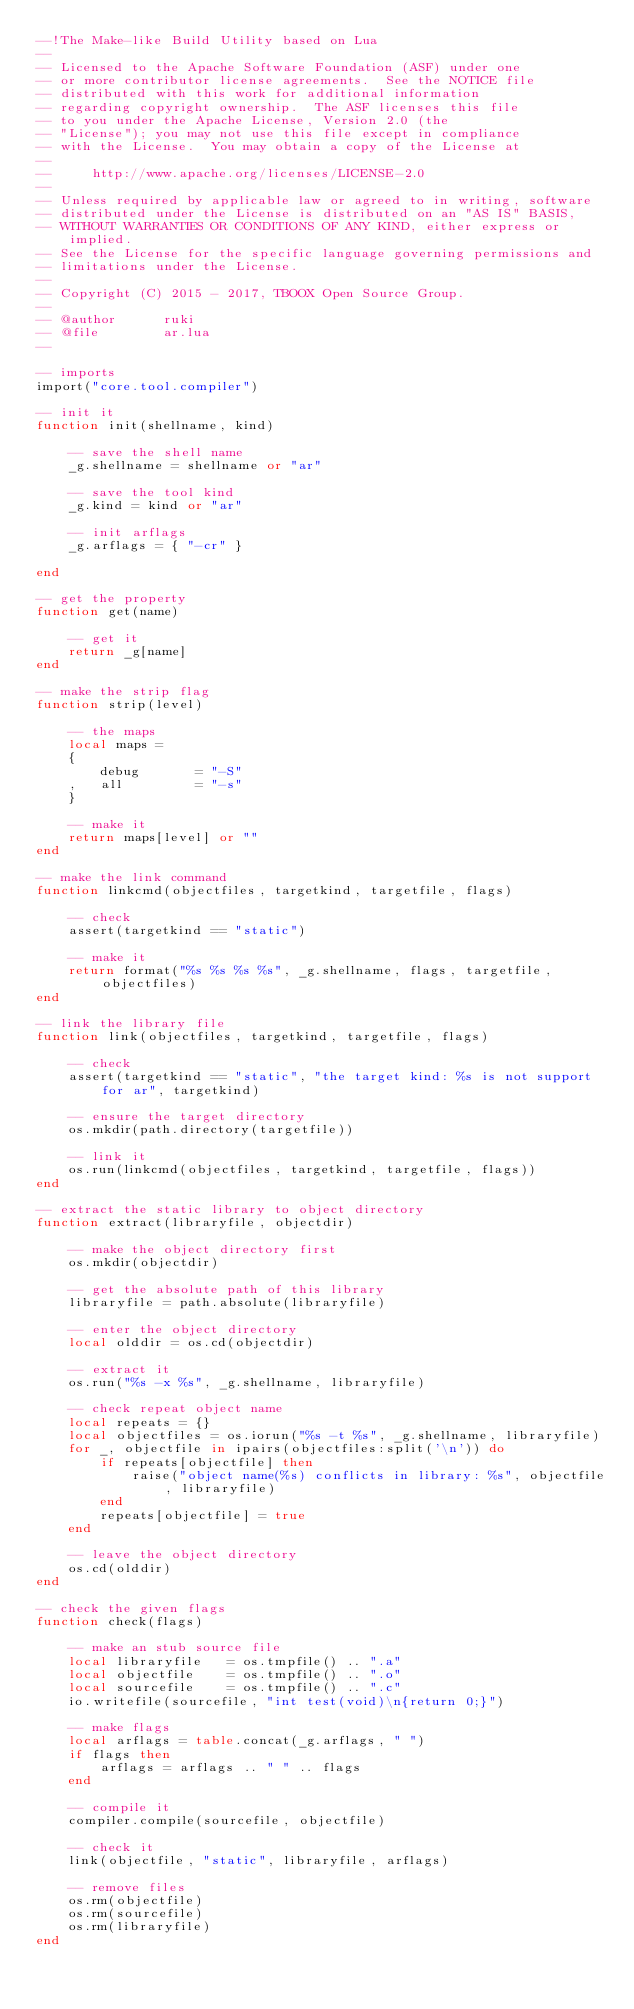<code> <loc_0><loc_0><loc_500><loc_500><_Lua_>--!The Make-like Build Utility based on Lua
--
-- Licensed to the Apache Software Foundation (ASF) under one
-- or more contributor license agreements.  See the NOTICE file
-- distributed with this work for additional information
-- regarding copyright ownership.  The ASF licenses this file
-- to you under the Apache License, Version 2.0 (the
-- "License"); you may not use this file except in compliance
-- with the License.  You may obtain a copy of the License at
--
--     http://www.apache.org/licenses/LICENSE-2.0
--
-- Unless required by applicable law or agreed to in writing, software
-- distributed under the License is distributed on an "AS IS" BASIS,
-- WITHOUT WARRANTIES OR CONDITIONS OF ANY KIND, either express or implied.
-- See the License for the specific language governing permissions and
-- limitations under the License.
-- 
-- Copyright (C) 2015 - 2017, TBOOX Open Source Group.
--
-- @author      ruki
-- @file        ar.lua
--

-- imports
import("core.tool.compiler")

-- init it
function init(shellname, kind)
    
    -- save the shell name
    _g.shellname = shellname or "ar"

    -- save the tool kind
    _g.kind = kind or "ar"

    -- init arflags
    _g.arflags = { "-cr" }

end

-- get the property
function get(name)

    -- get it
    return _g[name]
end

-- make the strip flag
function strip(level)

    -- the maps
    local maps = 
    {   
        debug       = "-S"
    ,   all         = "-s"
    }

    -- make it
    return maps[level] or ""
end

-- make the link command
function linkcmd(objectfiles, targetkind, targetfile, flags)

    -- check
    assert(targetkind == "static")

    -- make it
    return format("%s %s %s %s", _g.shellname, flags, targetfile, objectfiles)
end

-- link the library file
function link(objectfiles, targetkind, targetfile, flags)

    -- check
    assert(targetkind == "static", "the target kind: %s is not support for ar", targetkind)

    -- ensure the target directory
    os.mkdir(path.directory(targetfile))

    -- link it
    os.run(linkcmd(objectfiles, targetkind, targetfile, flags))
end

-- extract the static library to object directory
function extract(libraryfile, objectdir)

    -- make the object directory first
    os.mkdir(objectdir)

    -- get the absolute path of this library
    libraryfile = path.absolute(libraryfile)

    -- enter the object directory
    local olddir = os.cd(objectdir)

    -- extract it
    os.run("%s -x %s", _g.shellname, libraryfile)

    -- check repeat object name
    local repeats = {}
    local objectfiles = os.iorun("%s -t %s", _g.shellname, libraryfile)
    for _, objectfile in ipairs(objectfiles:split('\n')) do
        if repeats[objectfile] then
            raise("object name(%s) conflicts in library: %s", objectfile, libraryfile)
        end
        repeats[objectfile] = true
    end                                                          

    -- leave the object directory
    os.cd(olddir)
end

-- check the given flags 
function check(flags)

    -- make an stub source file
    local libraryfile   = os.tmpfile() .. ".a"
    local objectfile    = os.tmpfile() .. ".o"
    local sourcefile    = os.tmpfile() .. ".c"
    io.writefile(sourcefile, "int test(void)\n{return 0;}")

    -- make flags
    local arflags = table.concat(_g.arflags, " ")
    if flags then
        arflags = arflags .. " " .. flags
    end

    -- compile it
    compiler.compile(sourcefile, objectfile)

    -- check it
    link(objectfile, "static", libraryfile, arflags)

    -- remove files
    os.rm(objectfile)
    os.rm(sourcefile)
    os.rm(libraryfile)
end
</code> 